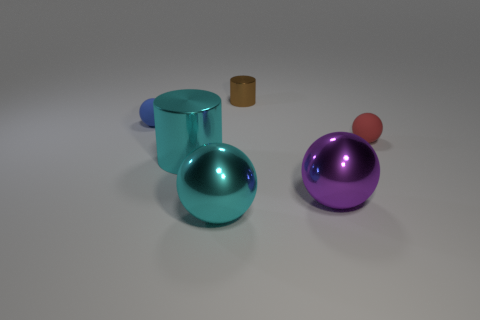Is there anything else that is the same color as the large cylinder?
Provide a succinct answer. Yes. What shape is the other tiny thing that is made of the same material as the purple thing?
Offer a terse response. Cylinder. Does the large cylinder have the same color as the tiny cylinder?
Give a very brief answer. No. Is the cylinder that is behind the small blue object made of the same material as the cylinder in front of the tiny blue rubber sphere?
Your answer should be compact. Yes. What number of objects are either large cyan cylinders or matte things that are right of the tiny blue matte sphere?
Give a very brief answer. 2. Are there any other things that have the same material as the blue ball?
Provide a succinct answer. Yes. What shape is the thing that is the same color as the large cylinder?
Keep it short and to the point. Sphere. What is the material of the big purple ball?
Ensure brevity in your answer.  Metal. Does the small cylinder have the same material as the tiny blue sphere?
Your answer should be very brief. No. What number of matte objects are small spheres or red spheres?
Keep it short and to the point. 2. 